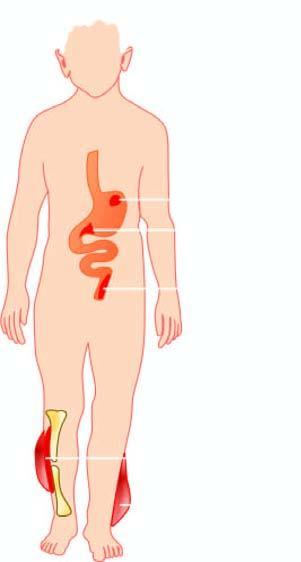what is causedd by clostridia?
Answer the question using a single word or phrase. Diseases 